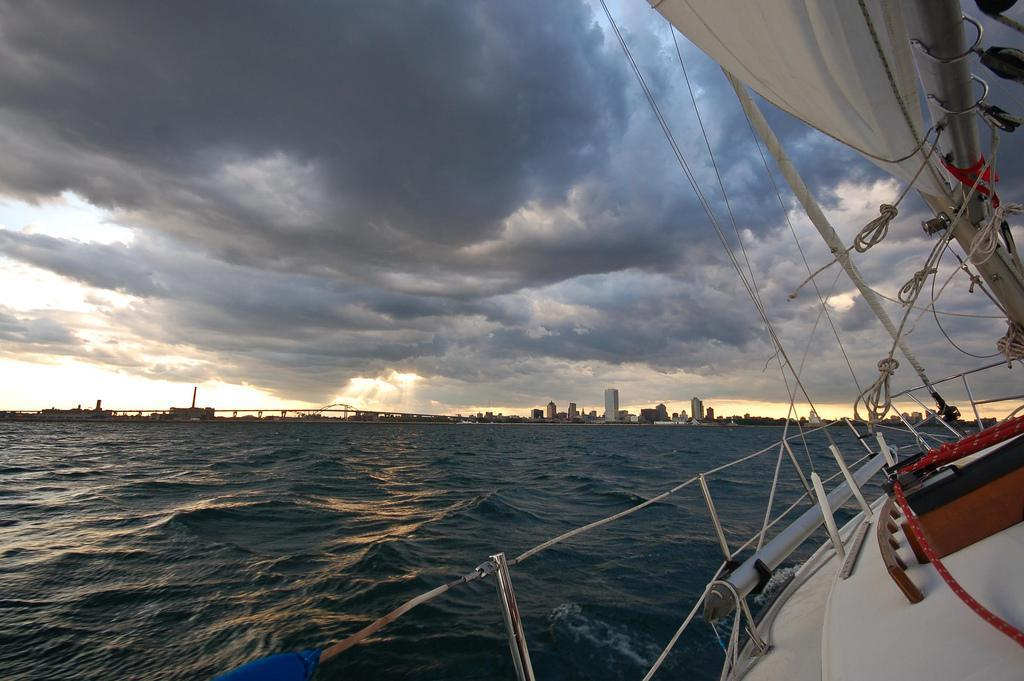What object is located on the right side of the image? There is a board on the right side of the image. What natural feature is on the left side of the image? There is a sea on the left side of the image. What is visible at the top of the image? The sky is visible at the top of the image. How would you describe the sky in the image? The sky appears to be cloudy. How many tickets are available for distribution at the gate in the image? There is no gate or tickets present in the image. What type of gate is depicted in the image? There is no gate present in the image. 